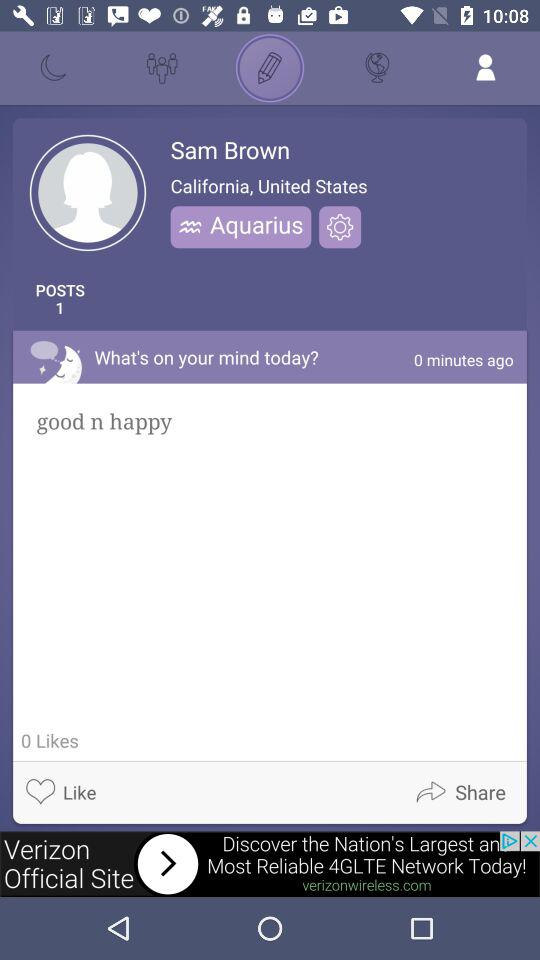How can the user share the content?
When the provided information is insufficient, respond with <no answer>. <no answer> 